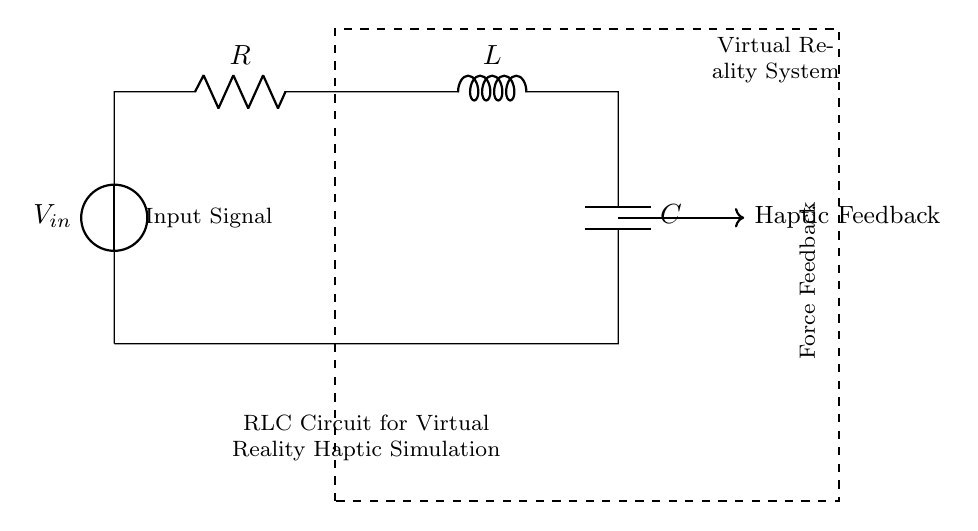What is the input voltage source labeled as? The input voltage source is labeled as V_in, indicating it provides the input voltage to the circuit.
Answer: V_in What components are present in this RLC circuit? The components present are a resistor (R), inductor (L), and capacitor (C). They are connected in series as part of the circuit configuration.
Answer: R, L, C What type of feedback is indicated in the circuit? The circuit diagram indicates "Haptic Feedback," which suggests that it is designed to provide tactile sensations to the user.
Answer: Haptic Feedback What is the purpose of the dashed rectangle in the circuit? The dashed rectangle signifies the boundaries of the virtual reality system, illustrating that the components within are part of that system's functionality.
Answer: Virtual Reality System How are the components connected in the circuit? The components are connected in series, meaning that the current flows sequentially through the resistor, inductor, and capacitor without branching.
Answer: Series What is the role of the inductor in this RLC circuit? The inductor plays a role in storing energy in a magnetic field and contributes to the circuit's reactance, affecting the overall impedance and transient response.
Answer: Energy storage 